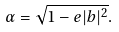Convert formula to latex. <formula><loc_0><loc_0><loc_500><loc_500>\alpha = \sqrt { 1 - e | b | ^ { 2 } } .</formula> 